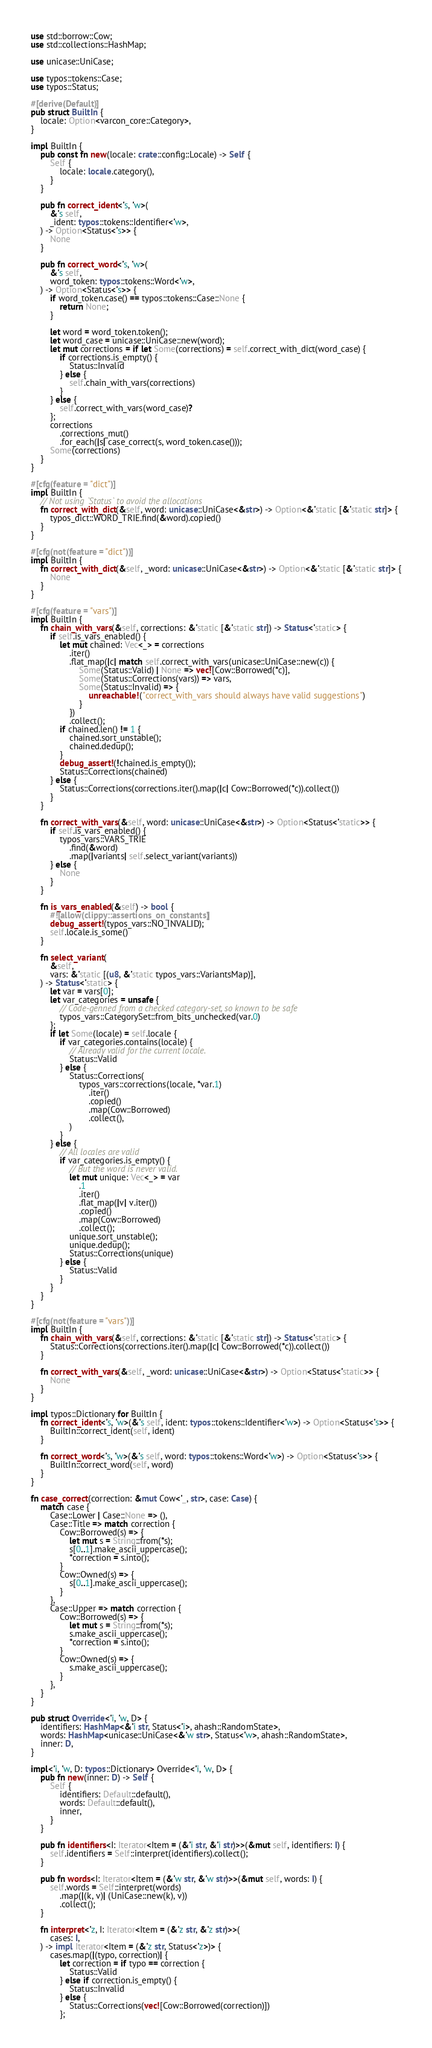<code> <loc_0><loc_0><loc_500><loc_500><_Rust_>use std::borrow::Cow;
use std::collections::HashMap;

use unicase::UniCase;

use typos::tokens::Case;
use typos::Status;

#[derive(Default)]
pub struct BuiltIn {
    locale: Option<varcon_core::Category>,
}

impl BuiltIn {
    pub const fn new(locale: crate::config::Locale) -> Self {
        Self {
            locale: locale.category(),
        }
    }

    pub fn correct_ident<'s, 'w>(
        &'s self,
        _ident: typos::tokens::Identifier<'w>,
    ) -> Option<Status<'s>> {
        None
    }

    pub fn correct_word<'s, 'w>(
        &'s self,
        word_token: typos::tokens::Word<'w>,
    ) -> Option<Status<'s>> {
        if word_token.case() == typos::tokens::Case::None {
            return None;
        }

        let word = word_token.token();
        let word_case = unicase::UniCase::new(word);
        let mut corrections = if let Some(corrections) = self.correct_with_dict(word_case) {
            if corrections.is_empty() {
                Status::Invalid
            } else {
                self.chain_with_vars(corrections)
            }
        } else {
            self.correct_with_vars(word_case)?
        };
        corrections
            .corrections_mut()
            .for_each(|s| case_correct(s, word_token.case()));
        Some(corrections)
    }
}

#[cfg(feature = "dict")]
impl BuiltIn {
    // Not using `Status` to avoid the allocations
    fn correct_with_dict(&self, word: unicase::UniCase<&str>) -> Option<&'static [&'static str]> {
        typos_dict::WORD_TRIE.find(&word).copied()
    }
}

#[cfg(not(feature = "dict"))]
impl BuiltIn {
    fn correct_with_dict(&self, _word: unicase::UniCase<&str>) -> Option<&'static [&'static str]> {
        None
    }
}

#[cfg(feature = "vars")]
impl BuiltIn {
    fn chain_with_vars(&self, corrections: &'static [&'static str]) -> Status<'static> {
        if self.is_vars_enabled() {
            let mut chained: Vec<_> = corrections
                .iter()
                .flat_map(|c| match self.correct_with_vars(unicase::UniCase::new(c)) {
                    Some(Status::Valid) | None => vec![Cow::Borrowed(*c)],
                    Some(Status::Corrections(vars)) => vars,
                    Some(Status::Invalid) => {
                        unreachable!("correct_with_vars should always have valid suggestions")
                    }
                })
                .collect();
            if chained.len() != 1 {
                chained.sort_unstable();
                chained.dedup();
            }
            debug_assert!(!chained.is_empty());
            Status::Corrections(chained)
        } else {
            Status::Corrections(corrections.iter().map(|c| Cow::Borrowed(*c)).collect())
        }
    }

    fn correct_with_vars(&self, word: unicase::UniCase<&str>) -> Option<Status<'static>> {
        if self.is_vars_enabled() {
            typos_vars::VARS_TRIE
                .find(&word)
                .map(|variants| self.select_variant(variants))
        } else {
            None
        }
    }

    fn is_vars_enabled(&self) -> bool {
        #![allow(clippy::assertions_on_constants)]
        debug_assert!(typos_vars::NO_INVALID);
        self.locale.is_some()
    }

    fn select_variant(
        &self,
        vars: &'static [(u8, &'static typos_vars::VariantsMap)],
    ) -> Status<'static> {
        let var = vars[0];
        let var_categories = unsafe {
            // Code-genned from a checked category-set, so known to be safe
            typos_vars::CategorySet::from_bits_unchecked(var.0)
        };
        if let Some(locale) = self.locale {
            if var_categories.contains(locale) {
                // Already valid for the current locale.
                Status::Valid
            } else {
                Status::Corrections(
                    typos_vars::corrections(locale, *var.1)
                        .iter()
                        .copied()
                        .map(Cow::Borrowed)
                        .collect(),
                )
            }
        } else {
            // All locales are valid
            if var_categories.is_empty() {
                // But the word is never valid.
                let mut unique: Vec<_> = var
                    .1
                    .iter()
                    .flat_map(|v| v.iter())
                    .copied()
                    .map(Cow::Borrowed)
                    .collect();
                unique.sort_unstable();
                unique.dedup();
                Status::Corrections(unique)
            } else {
                Status::Valid
            }
        }
    }
}

#[cfg(not(feature = "vars"))]
impl BuiltIn {
    fn chain_with_vars(&self, corrections: &'static [&'static str]) -> Status<'static> {
        Status::Corrections(corrections.iter().map(|c| Cow::Borrowed(*c)).collect())
    }

    fn correct_with_vars(&self, _word: unicase::UniCase<&str>) -> Option<Status<'static>> {
        None
    }
}

impl typos::Dictionary for BuiltIn {
    fn correct_ident<'s, 'w>(&'s self, ident: typos::tokens::Identifier<'w>) -> Option<Status<'s>> {
        BuiltIn::correct_ident(self, ident)
    }

    fn correct_word<'s, 'w>(&'s self, word: typos::tokens::Word<'w>) -> Option<Status<'s>> {
        BuiltIn::correct_word(self, word)
    }
}

fn case_correct(correction: &mut Cow<'_, str>, case: Case) {
    match case {
        Case::Lower | Case::None => (),
        Case::Title => match correction {
            Cow::Borrowed(s) => {
                let mut s = String::from(*s);
                s[0..1].make_ascii_uppercase();
                *correction = s.into();
            }
            Cow::Owned(s) => {
                s[0..1].make_ascii_uppercase();
            }
        },
        Case::Upper => match correction {
            Cow::Borrowed(s) => {
                let mut s = String::from(*s);
                s.make_ascii_uppercase();
                *correction = s.into();
            }
            Cow::Owned(s) => {
                s.make_ascii_uppercase();
            }
        },
    }
}

pub struct Override<'i, 'w, D> {
    identifiers: HashMap<&'i str, Status<'i>, ahash::RandomState>,
    words: HashMap<unicase::UniCase<&'w str>, Status<'w>, ahash::RandomState>,
    inner: D,
}

impl<'i, 'w, D: typos::Dictionary> Override<'i, 'w, D> {
    pub fn new(inner: D) -> Self {
        Self {
            identifiers: Default::default(),
            words: Default::default(),
            inner,
        }
    }

    pub fn identifiers<I: Iterator<Item = (&'i str, &'i str)>>(&mut self, identifiers: I) {
        self.identifiers = Self::interpret(identifiers).collect();
    }

    pub fn words<I: Iterator<Item = (&'w str, &'w str)>>(&mut self, words: I) {
        self.words = Self::interpret(words)
            .map(|(k, v)| (UniCase::new(k), v))
            .collect();
    }

    fn interpret<'z, I: Iterator<Item = (&'z str, &'z str)>>(
        cases: I,
    ) -> impl Iterator<Item = (&'z str, Status<'z>)> {
        cases.map(|(typo, correction)| {
            let correction = if typo == correction {
                Status::Valid
            } else if correction.is_empty() {
                Status::Invalid
            } else {
                Status::Corrections(vec![Cow::Borrowed(correction)])
            };</code> 